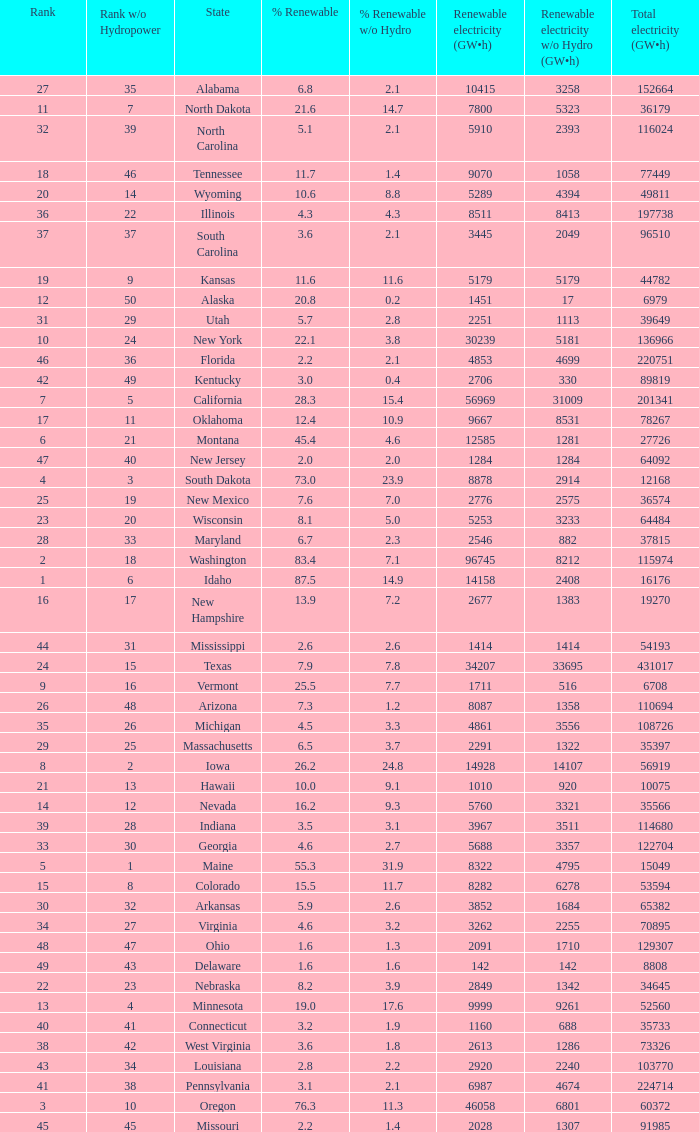What is the amount of renewable electricity without hydrogen power when the percentage of renewable energy is 83.4? 8212.0. 